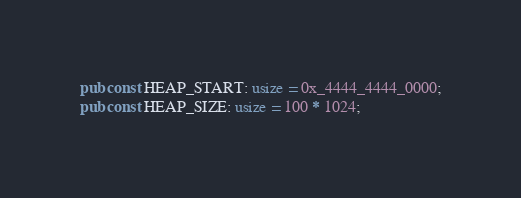Convert code to text. <code><loc_0><loc_0><loc_500><loc_500><_Rust_>pub const HEAP_START: usize = 0x_4444_4444_0000;
pub const HEAP_SIZE: usize = 100 * 1024;
</code> 